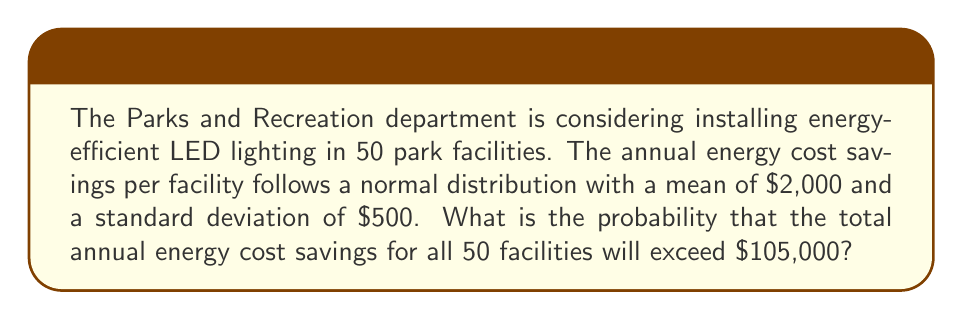Give your solution to this math problem. Let's approach this step-by-step:

1) Let X be the random variable representing the total annual energy cost savings for all 50 facilities.

2) Given:
   - Each facility's savings follows N($\mu = 2000$, $\sigma = 500$)
   - There are 50 facilities

3) The sum of normally distributed random variables is also normally distributed. Therefore, X follows a normal distribution with:
   
   $\mu_X = 50 \times 2000 = 100,000$
   $\sigma_X = \sqrt{50} \times 500 = 3535.53$ (using the property of variance for sum of independent variables)

4) We want to find P(X > 105,000)

5) To standardize, we calculate the z-score:

   $$z = \frac{x - \mu}{\sigma} = \frac{105,000 - 100,000}{3535.53} = 1.41$$

6) We need to find P(Z > 1.41) where Z is the standard normal distribution

7) Using a standard normal table or calculator:
   P(Z > 1.41) = 1 - P(Z < 1.41) = 1 - 0.9207 = 0.0793

Therefore, the probability that the total annual energy cost savings for all 50 facilities will exceed $105,000 is approximately 0.0793 or 7.93%.
Answer: 0.0793 